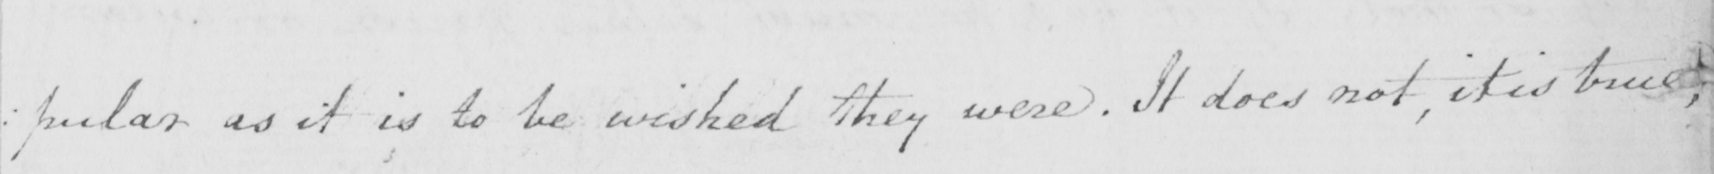Transcribe the text shown in this historical manuscript line. : pular as it is to be wished they were . It does not , it is true , 